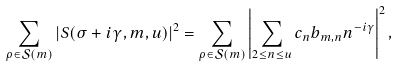Convert formula to latex. <formula><loc_0><loc_0><loc_500><loc_500>\sum _ { \rho \in \mathcal { S } ( m ) } \left | S ( \sigma + i \gamma , m , u ) \right | ^ { 2 } = \sum _ { \rho \in \mathcal { S } ( m ) } \left | \sum _ { 2 \leq n \leq u } c _ { n } b _ { m , n } n ^ { - i \gamma } \right | ^ { 2 } ,</formula> 